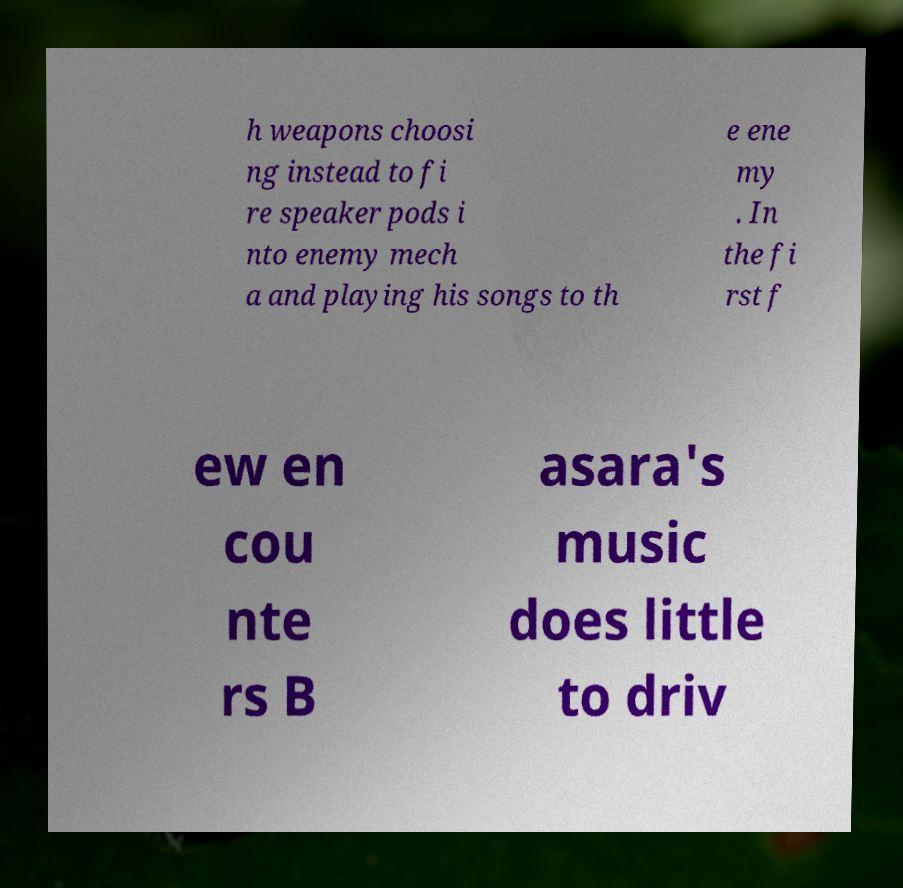Can you accurately transcribe the text from the provided image for me? h weapons choosi ng instead to fi re speaker pods i nto enemy mech a and playing his songs to th e ene my . In the fi rst f ew en cou nte rs B asara's music does little to driv 